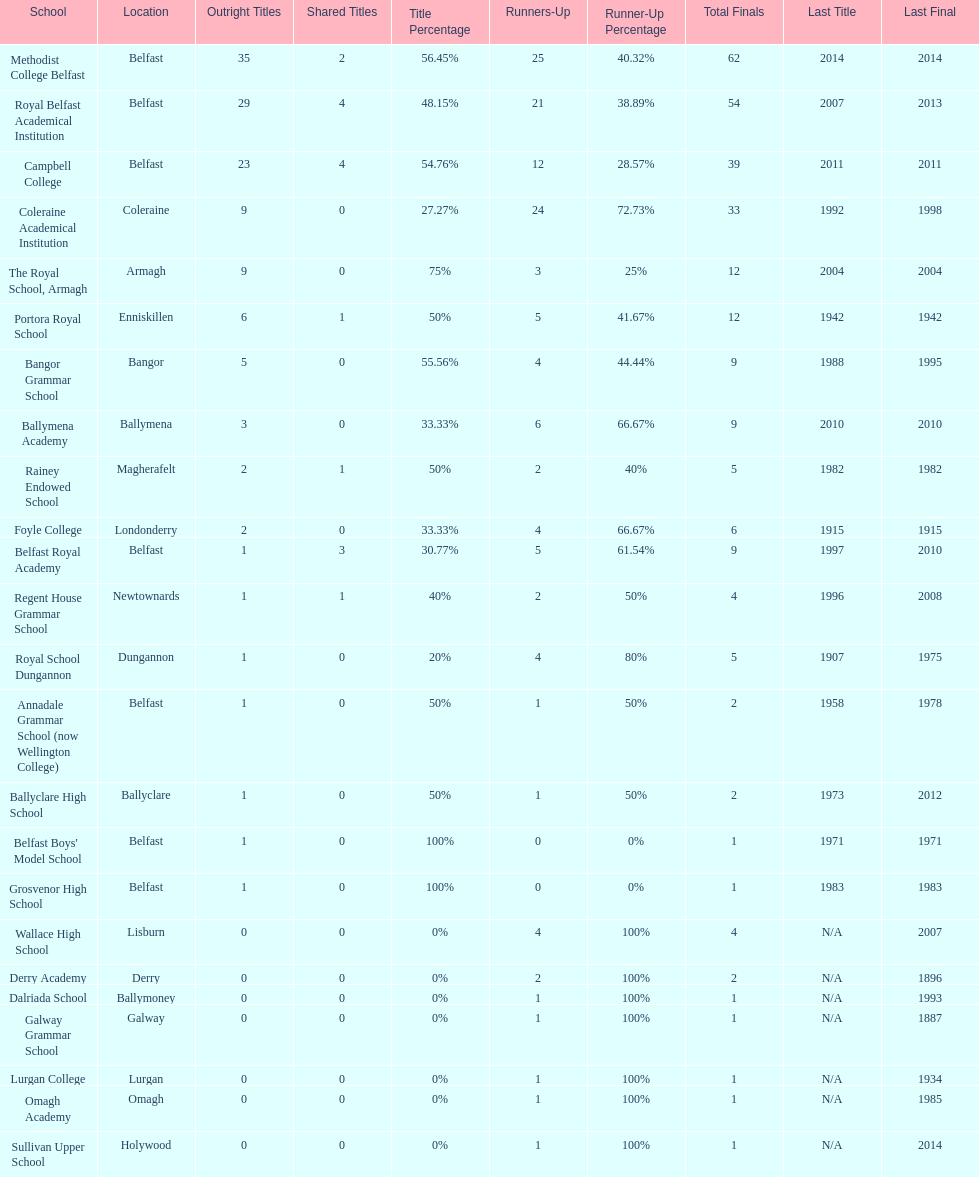How many schools have had at least 3 share titles? 3. 